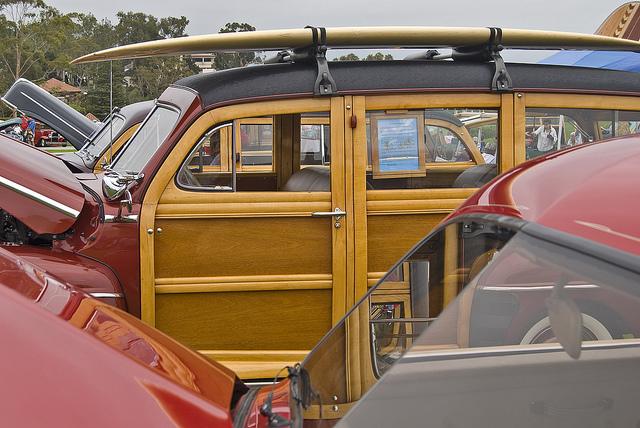What is on the hood?
Concise answer only. Surfboard. Is that all metal?
Short answer required. No. What type of vehicle has the surfboard on top?
Give a very brief answer. Station wagon. 